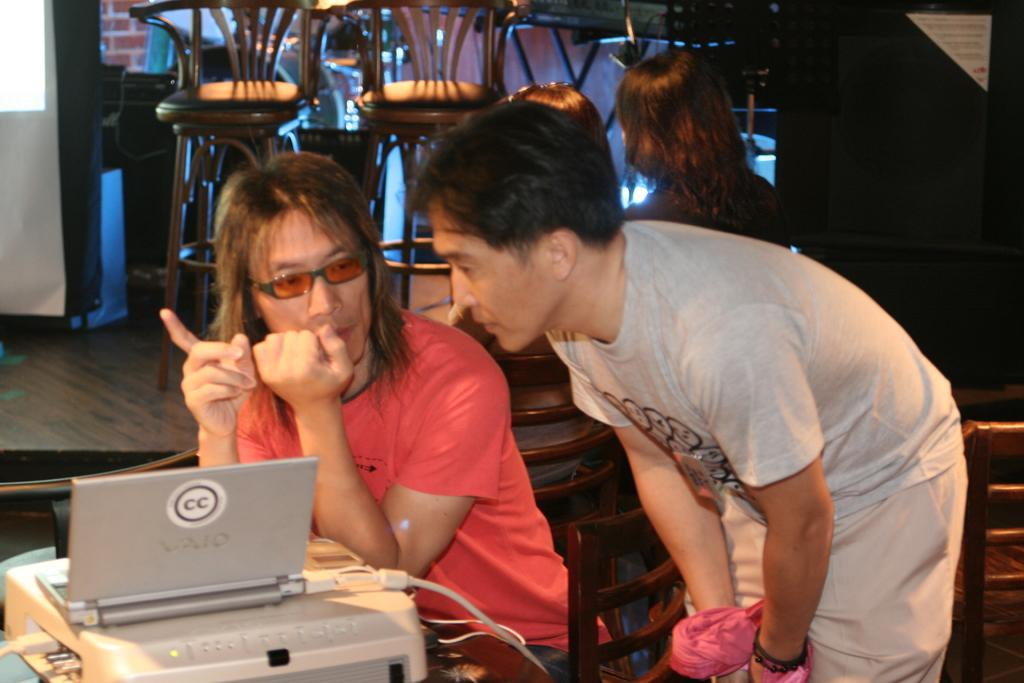<image>
Describe the image concisely. a boy is standing next to a cc laptop 